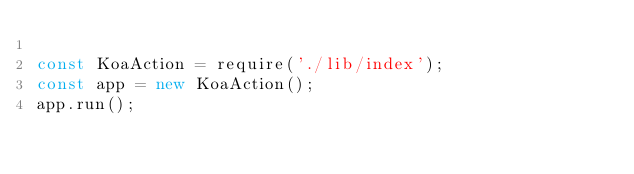<code> <loc_0><loc_0><loc_500><loc_500><_JavaScript_>
const KoaAction = require('./lib/index');
const app = new KoaAction();
app.run();
</code> 